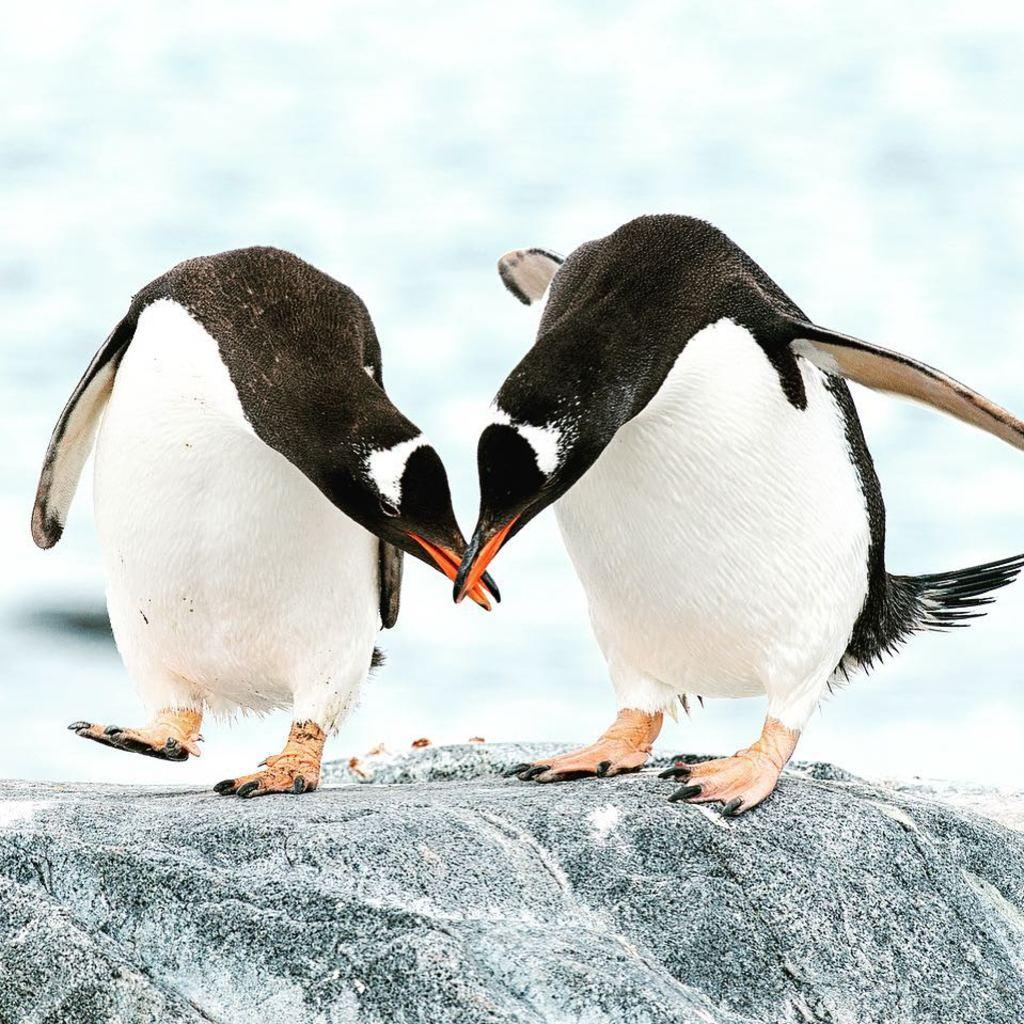How many penguins are in the image? There are two penguins in the image. Where are the penguins located? The penguins are on a rock. What colors are the penguins? The penguins are in white and black color. What colors are present in the background of the image? The background of the image is in blue and white color. What type of marble is the penguin holding in the image? There is no marble present in the image; the penguins are on a rock, and there are no objects in their possession. 